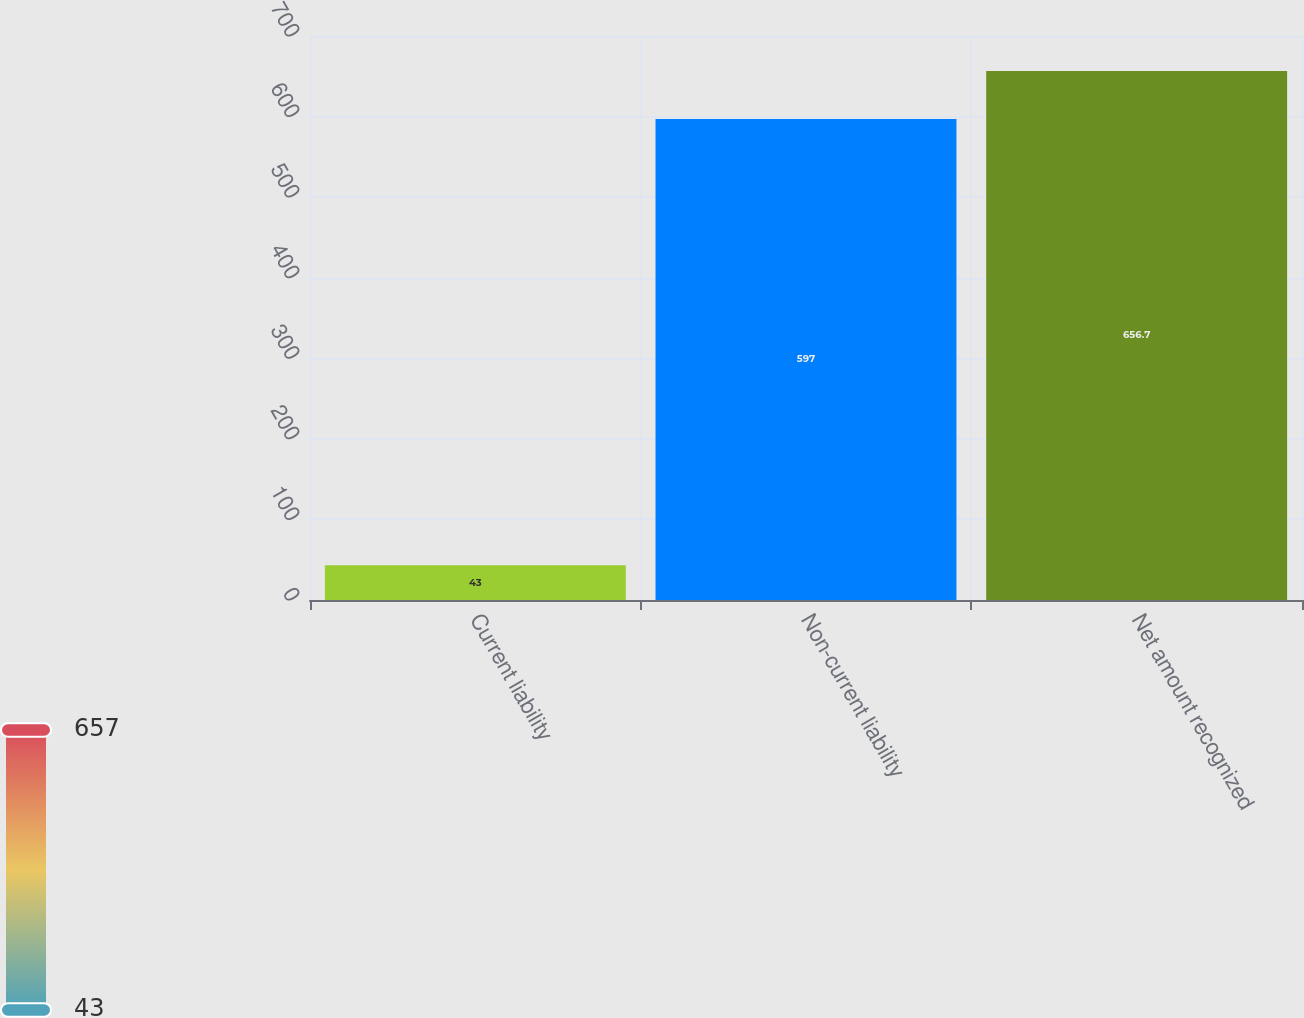<chart> <loc_0><loc_0><loc_500><loc_500><bar_chart><fcel>Current liability<fcel>Non-current liability<fcel>Net amount recognized<nl><fcel>43<fcel>597<fcel>656.7<nl></chart> 